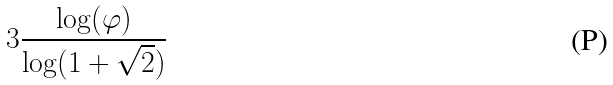Convert formula to latex. <formula><loc_0><loc_0><loc_500><loc_500>3 \frac { \log ( \varphi ) } { \log ( 1 + \sqrt { 2 } ) }</formula> 